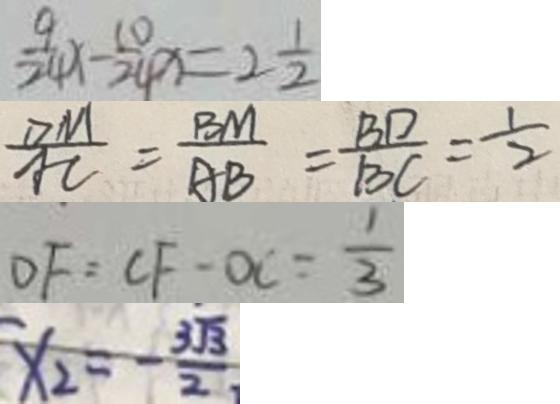Convert formula to latex. <formula><loc_0><loc_0><loc_500><loc_500>\frac { 9 } { 2 4 } x - \frac { 1 0 } { 2 4 } x = 2 \frac { 1 } { 2 } 
 \frac { D M } { A C } = \frac { B M } { A B } = \frac { B D } { B C } = \frac { 1 } { 2 } 
 D F = C F - O C = \frac { 1 } { 3 } 
 x _ { 2 } = - \frac { 3 \sqrt { 3 } } { 2 }</formula> 